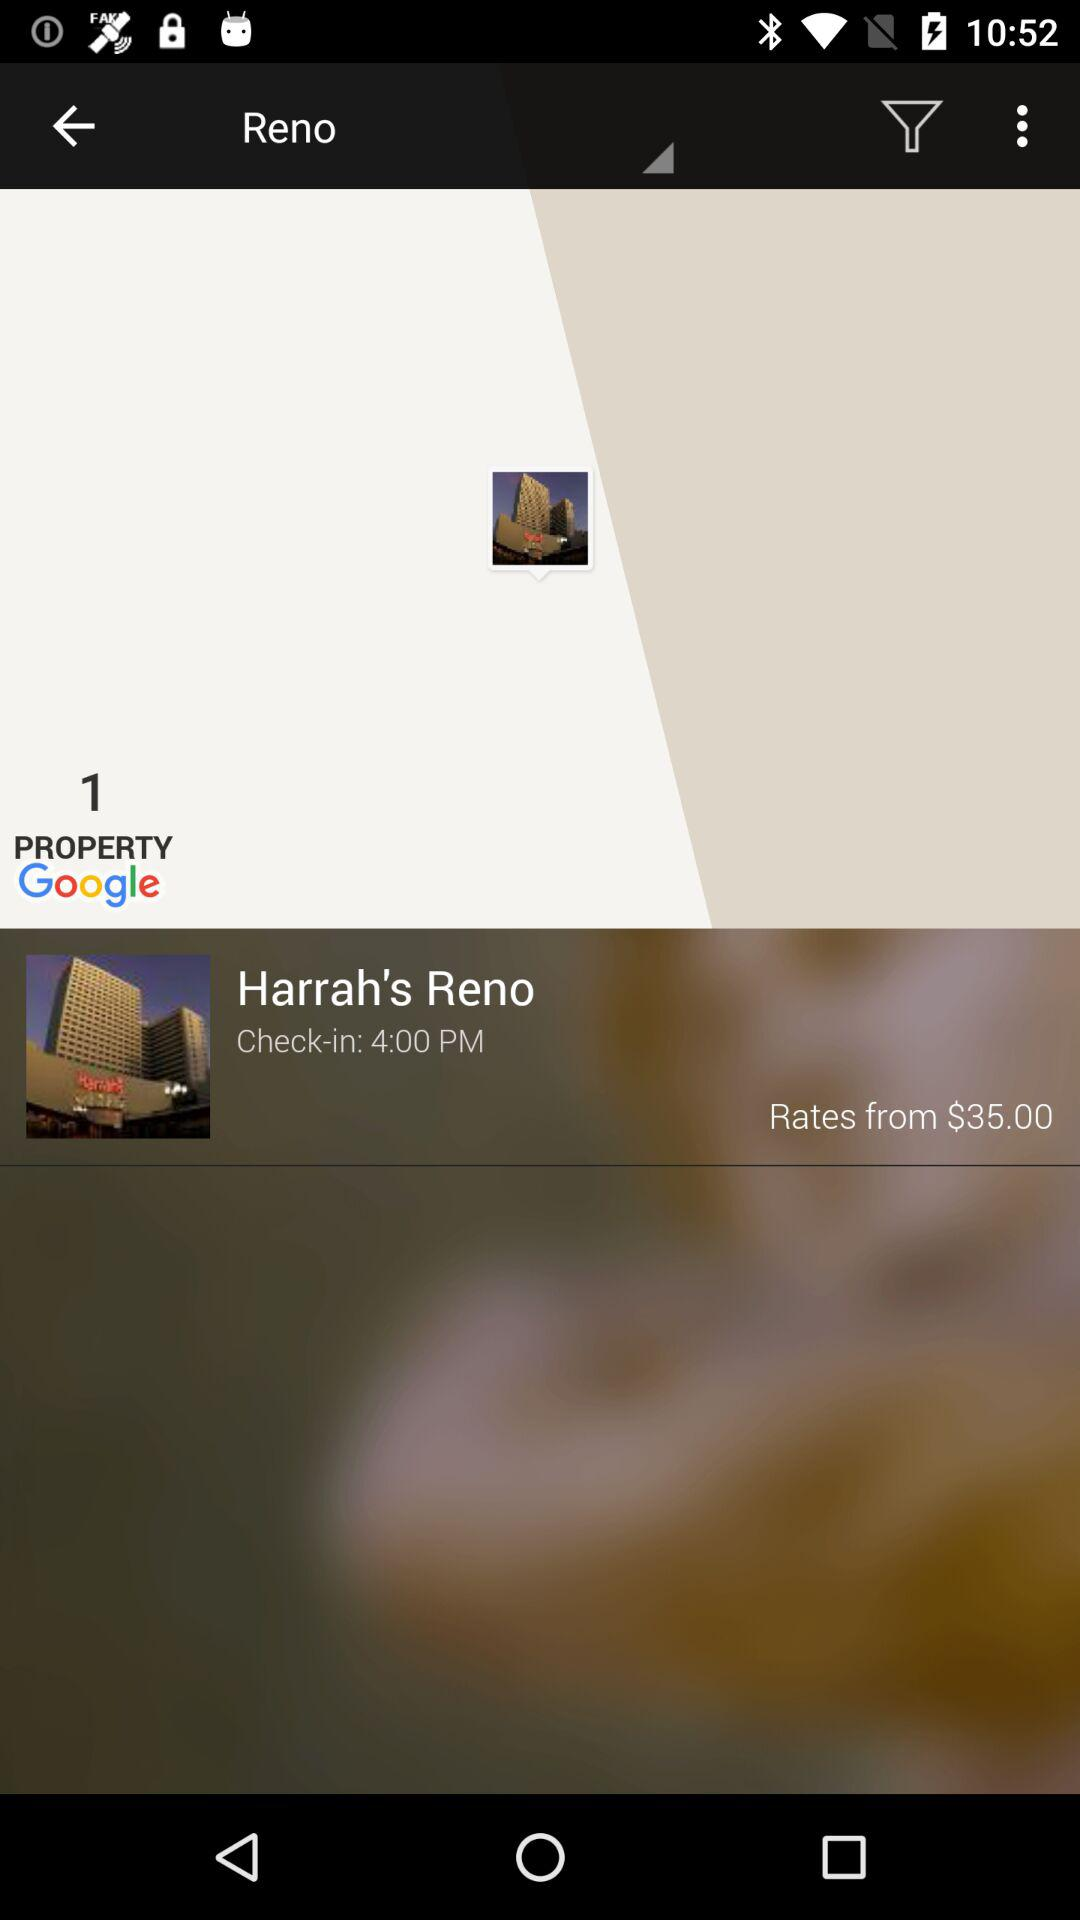How many properties are shown on the screen? There is 1 property shown on the screen. 